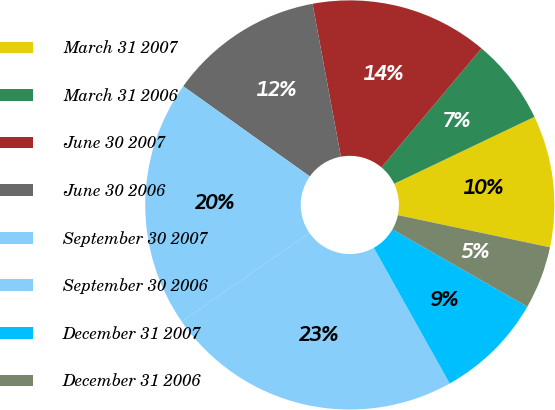<chart> <loc_0><loc_0><loc_500><loc_500><pie_chart><fcel>March 31 2007<fcel>March 31 2006<fcel>June 30 2007<fcel>June 30 2006<fcel>September 30 2007<fcel>September 30 2006<fcel>December 31 2007<fcel>December 31 2006<nl><fcel>10.41%<fcel>6.78%<fcel>14.05%<fcel>12.23%<fcel>19.5%<fcel>23.47%<fcel>8.6%<fcel>4.96%<nl></chart> 